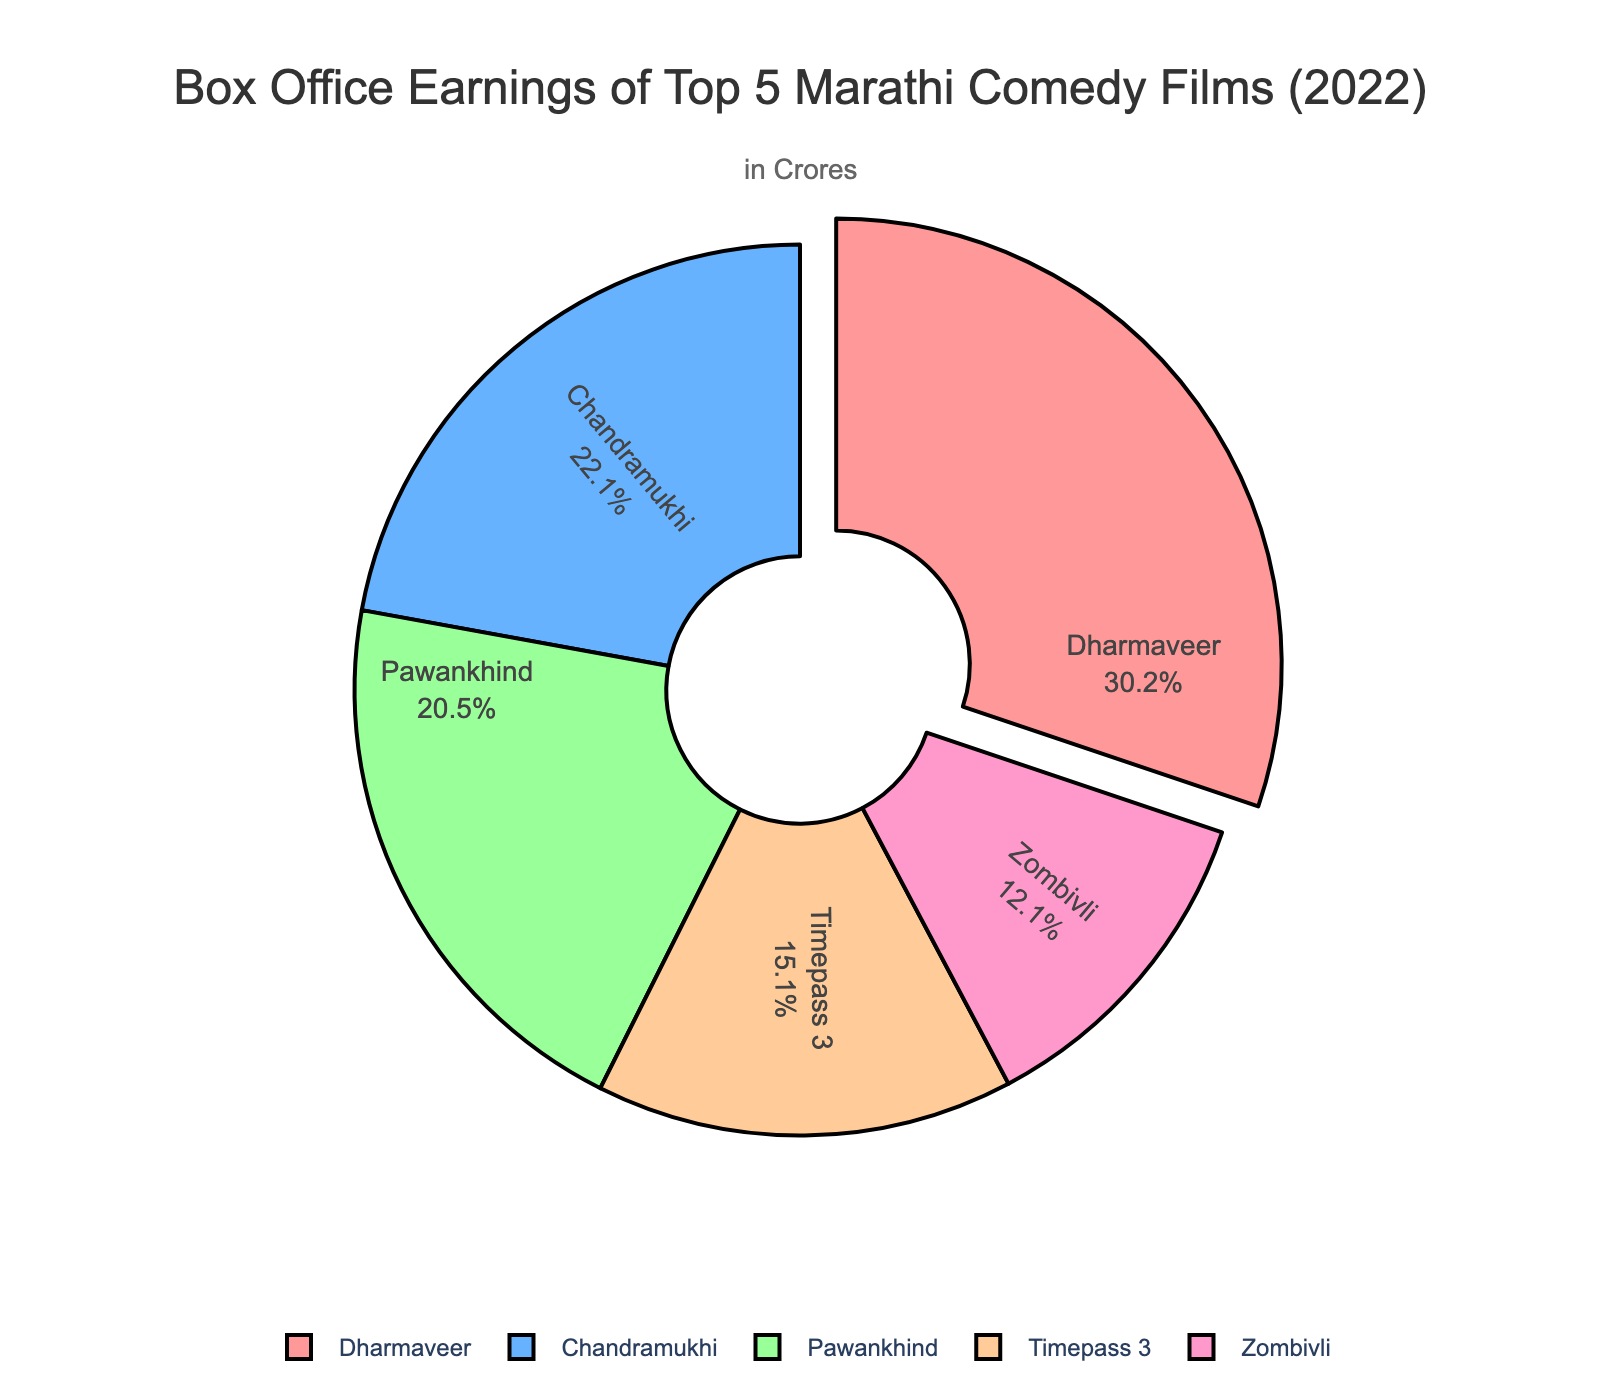Which film has the highest box office earnings? From the pie chart, the largest segment typically represents the film with the highest box office earnings. Here, "Dharmaveer" is highlighted and pulled out from the chart, indicating it has the highest earnings.
Answer: Dharmaveer What percentage of the total box office earnings is contributed by "Chandramukhi"? The percentage can be read directly from the pie chart where "Chandramukhi" is labeled. The chart shows "Chandramukhi" contributes 21.2% of the total box office earnings.
Answer: 21.2% How much more did "Dharmaveer" earn compared to "Zombivli"? To find this, we subtract the earnings of "Zombivli" from "Dharmaveer". Dharmaveer earned 25.5 crores and Zombivli earned 10.2 crores. So, 25.5 - 10.2 = 15.3 crores.
Answer: 15.3 crores What is the combined box office earnings of "Timepass 3" and "Pawankhind"? Add the earnings of "Timepass 3" (12.8 crores) and "Pawankhind" (17.3 crores) together. 12.8 + 17.3 = 30.1 crores.
Answer: 30.1 crores Which film earned less: "Pawankhind" or "Zombivli"? From the pie chart, the segment representing "Zombivli" is smaller compared to "Pawankhind", indicating that "Zombivli" earned less.
Answer: Zombivli What is the difference in box office earnings between "Chandramukhi" and "Timepass 3"? Subtract the earnings of "Timepass 3" (12.8 crores) from "Chandramukhi" (18.7 crores). 18.7 - 12.8 = 5.9 crores.
Answer: 5.9 crores Is "Pawankhind" closer in earnings to "Dharmaveer" or "Chandramukhi"? Calculate the difference between "Pawankhind" and the other two films. Dharmaveer: 25.5 - 17.3 = 8.2 crores, Chandramukhi: 18.7 - 17.3 = 1.4 crores. "Pawankhind" is closer in earnings to "Chandramukhi".
Answer: Chandramukhi Among the top 5 films, which film has the smallest section in the pie chart? The smallest section in the pie chart represents the film with the lowest earnings. From the chart, "Zombivli" has the smallest section.
Answer: Zombivli What is the total box office earning for the top 5 Marathi comedy films of 2022? Add up the earnings of all five films. 25.5 + 18.7 + 17.3 + 12.8 + 10.2 = 84.5 crores.
Answer: 84.5 crores Approximately, what is the average box office earnings for these top 5 films? To find the average earnings, divide the total earnings by the number of films. Total earnings = 84.5 crores, number of films = 5. So, 84.5 / 5 = 16.9 crores.
Answer: 16.9 crores 